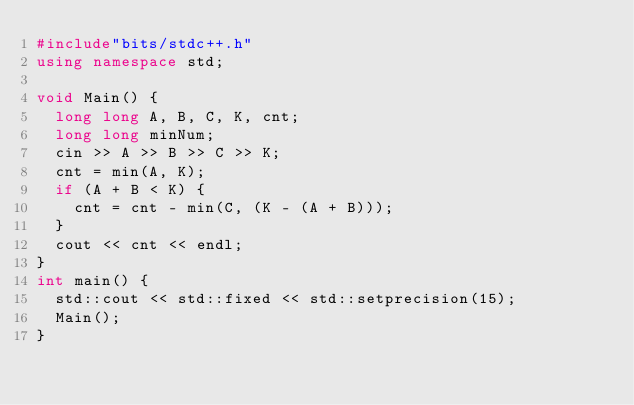<code> <loc_0><loc_0><loc_500><loc_500><_C++_>#include"bits/stdc++.h"
using namespace std;

void Main() {
	long long A, B, C, K, cnt;
	long long minNum;
	cin >> A >> B >> C >> K;
	cnt = min(A, K);
	if (A + B < K) {
		cnt = cnt - min(C, (K - (A + B)));
	}
	cout << cnt << endl;
}
int main() {
	std::cout << std::fixed << std::setprecision(15);
	Main();
}
</code> 